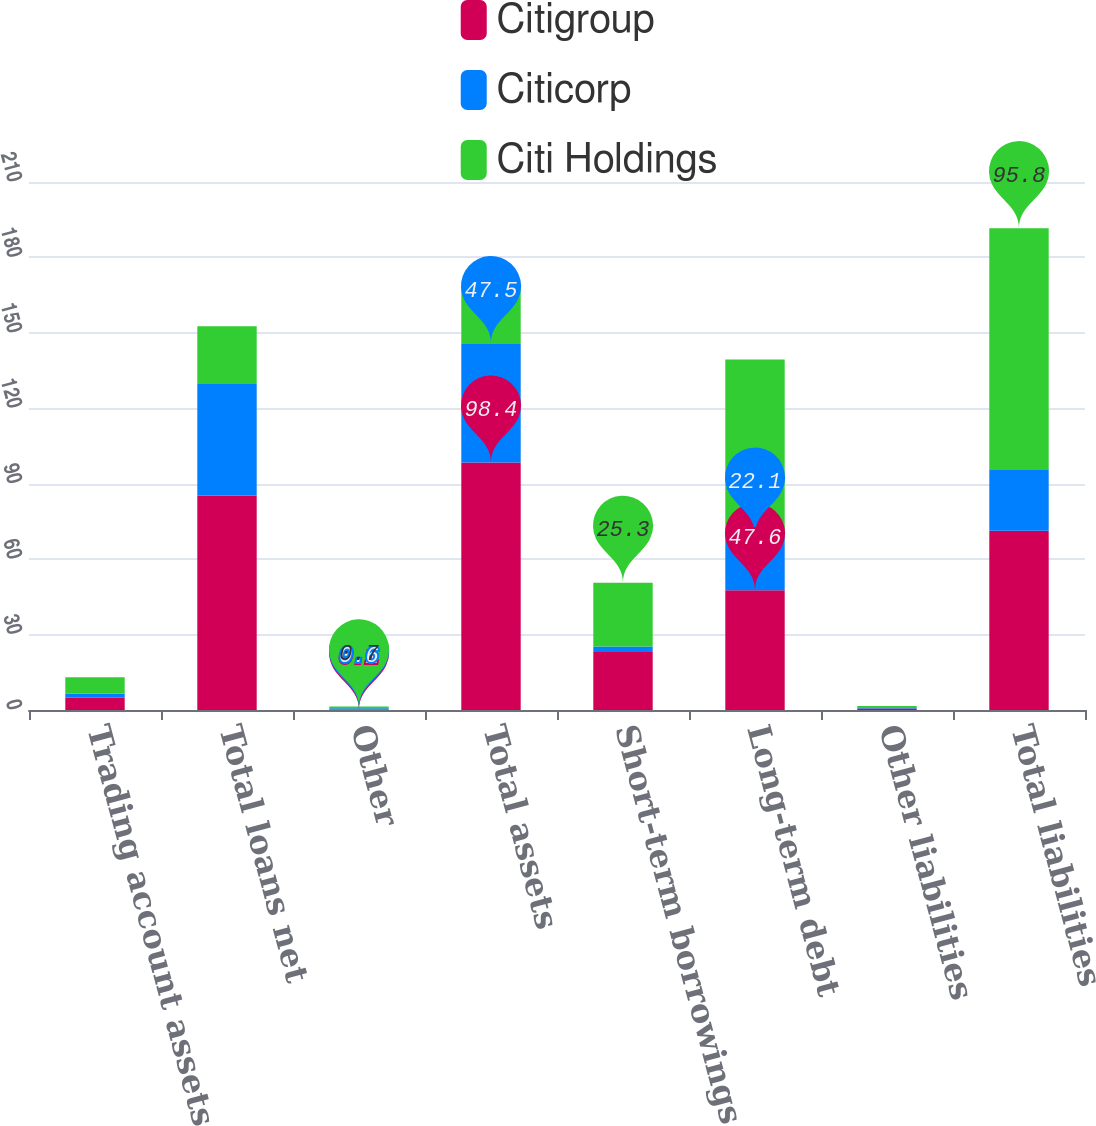<chart> <loc_0><loc_0><loc_500><loc_500><stacked_bar_chart><ecel><fcel>Trading account assets<fcel>Total loans net<fcel>Other<fcel>Total assets<fcel>Short-term borrowings<fcel>Long-term debt<fcel>Other liabilities<fcel>Total liabilities<nl><fcel>Citigroup<fcel>4.9<fcel>85.3<fcel>0.1<fcel>98.4<fcel>23.1<fcel>47.6<fcel>0.6<fcel>71.3<nl><fcel>Citicorp<fcel>1.6<fcel>44.7<fcel>0.6<fcel>47.5<fcel>2.2<fcel>22.1<fcel>0.2<fcel>24.5<nl><fcel>Citi Holdings<fcel>6.5<fcel>22.6<fcel>0.7<fcel>22.6<fcel>25.3<fcel>69.7<fcel>0.8<fcel>95.8<nl></chart> 